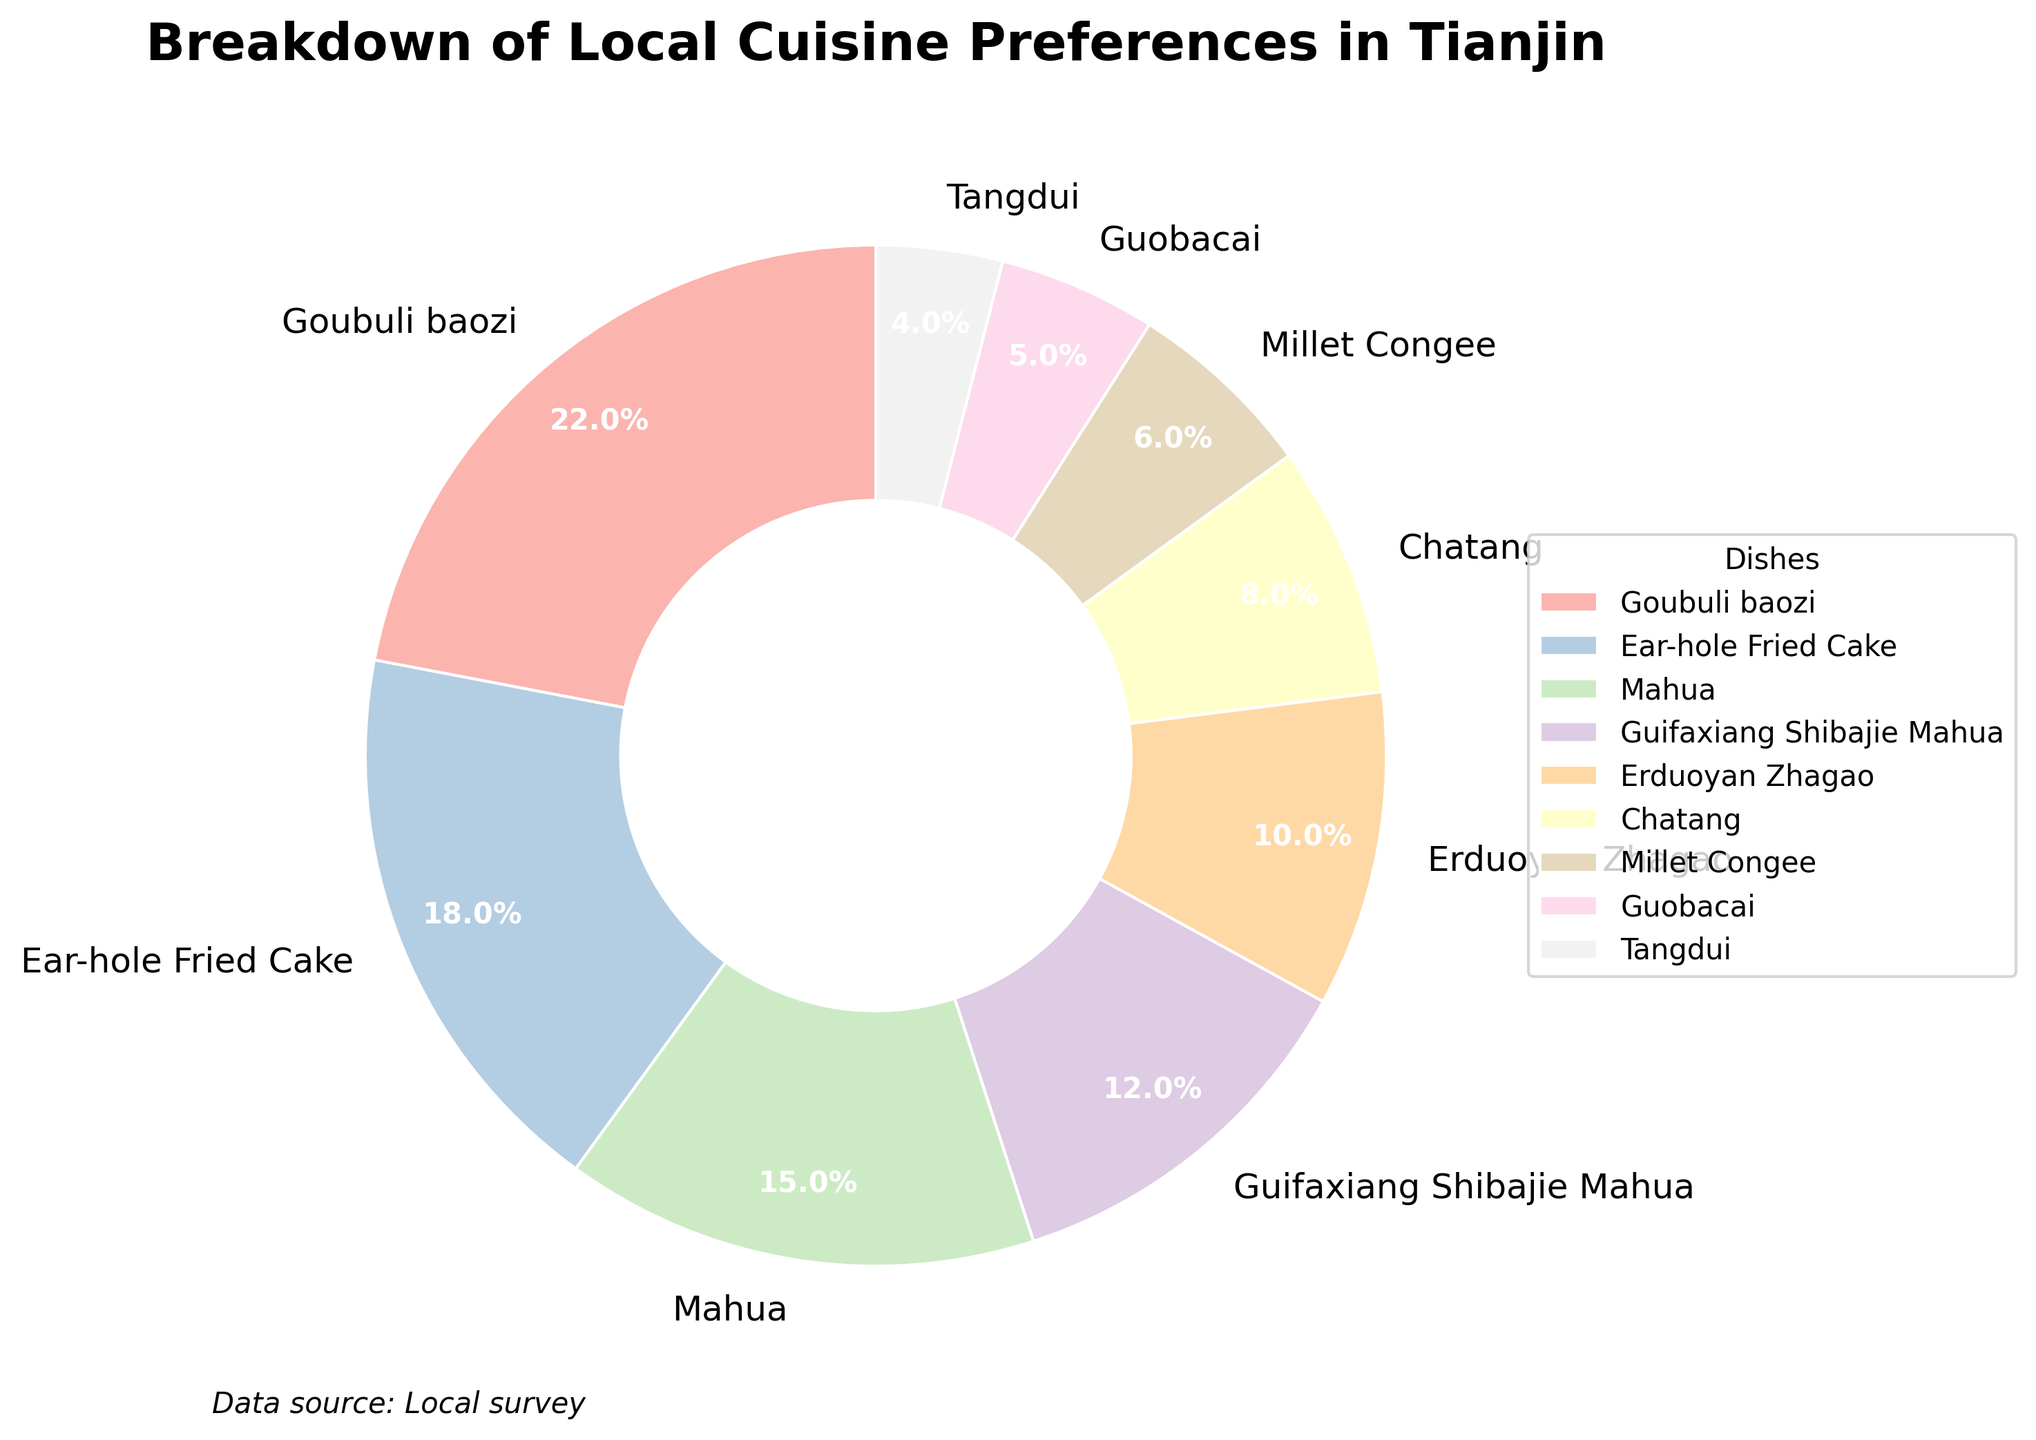1. What percentage of Tianjin residents prefer Goubuli baozi? From the pie chart, the percentage next to Goubuli baozi is clearly visible as 22%.
Answer: 22% 2. How much more popular is Ear-hole Fried Cake than Guobacai? Ear-hole Fried Cake is shown at 18%, and Guobacai is shown at 5%. The difference in their popularity is 18% - 5% = 13%.
Answer: 13% 3. Which dish is preferred by the least number of Tianjin residents? Looking at the slices and percentages, Tangdui is the smallest slice and has the lowest percentage at 4%.
Answer: Tangdui 4. What are the three most popular dishes among Tianjin residents, based on the pie chart? From the pie chart, the three largest slices belong to Goubuli baozi (22%), Ear-hole Fried Cake (18%), and Mahua (15%).
Answer: Goubuli baozi, Ear-hole Fried Cake, Mahua 5. How much of the total preference do the top two dishes account for? The top two dishes are Goubuli baozi (22%) and Ear-hole Fried Cake (18%). Their combined percentage is 22% + 18% = 40%.
Answer: 40% 6. Which dish has a preference just above 10%? The pie chart shows Guifaxiang Shibajie Mahua with a percentage of 12%, which is just above 10%.
Answer: Guifaxiang Shibajie Mahua 7. Is Chatang preferred by more or fewer residents than Millet Congee? Chatang has a slice representing 8%, while Millet Congee has a slice representing 6%. 8% is greater than 6%, so Chatang is preferred by more residents.
Answer: More 8. What colors are used to represent the largest and smallest slices on the pie chart? Goubuli baozi (largest) and Tangdui (smallest) are represented by pastel shades, but exact colors are not specified. Identify by slice size comparison: the largest in hues and the smallest in hues
Answer: Pastel shades (depends on pie chart color scheme) 9. If you combine the preferences for Chatang and Guobacai, what percentage of residents prefer these two dishes together? Chatang accounts for 8% and Guobacai accounts for 5%. Combined, they account for 8% + 5% = 13%.
Answer: 13% 10. Which two dishes have their preference percentages closest to each other? The preference percentages that are closest in value are Erduoyan Zhagao (10%) and Chatang (8%), with a difference of only 2%.
Answer: Erduoyan Zhagao and Chatang 